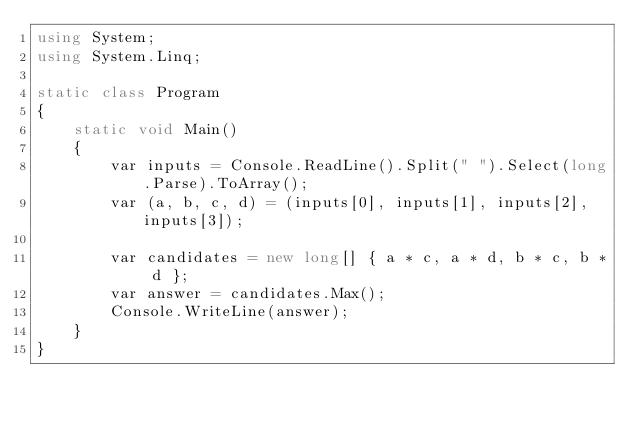<code> <loc_0><loc_0><loc_500><loc_500><_C#_>using System;
using System.Linq;

static class Program
{
    static void Main()
    {
        var inputs = Console.ReadLine().Split(" ").Select(long.Parse).ToArray();
        var (a, b, c, d) = (inputs[0], inputs[1], inputs[2], inputs[3]);

        var candidates = new long[] { a * c, a * d, b * c, b * d };
        var answer = candidates.Max();
        Console.WriteLine(answer);
    }
}</code> 